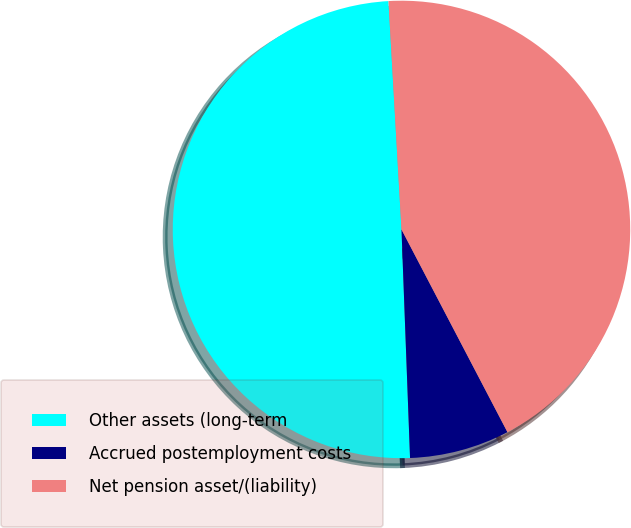Convert chart. <chart><loc_0><loc_0><loc_500><loc_500><pie_chart><fcel>Other assets (long-term<fcel>Accrued postemployment costs<fcel>Net pension asset/(liability)<nl><fcel>49.69%<fcel>7.07%<fcel>43.24%<nl></chart> 